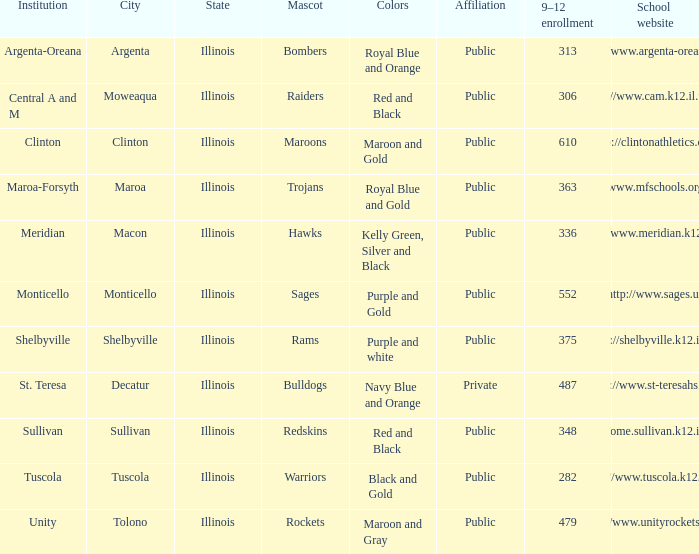What are the team colors from Tolono, Illinois? Maroon and Gray. 